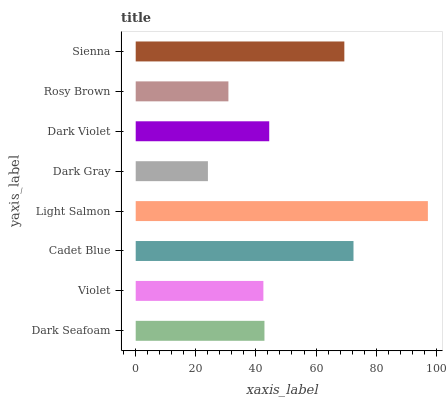Is Dark Gray the minimum?
Answer yes or no. Yes. Is Light Salmon the maximum?
Answer yes or no. Yes. Is Violet the minimum?
Answer yes or no. No. Is Violet the maximum?
Answer yes or no. No. Is Dark Seafoam greater than Violet?
Answer yes or no. Yes. Is Violet less than Dark Seafoam?
Answer yes or no. Yes. Is Violet greater than Dark Seafoam?
Answer yes or no. No. Is Dark Seafoam less than Violet?
Answer yes or no. No. Is Dark Violet the high median?
Answer yes or no. Yes. Is Dark Seafoam the low median?
Answer yes or no. Yes. Is Dark Gray the high median?
Answer yes or no. No. Is Dark Violet the low median?
Answer yes or no. No. 